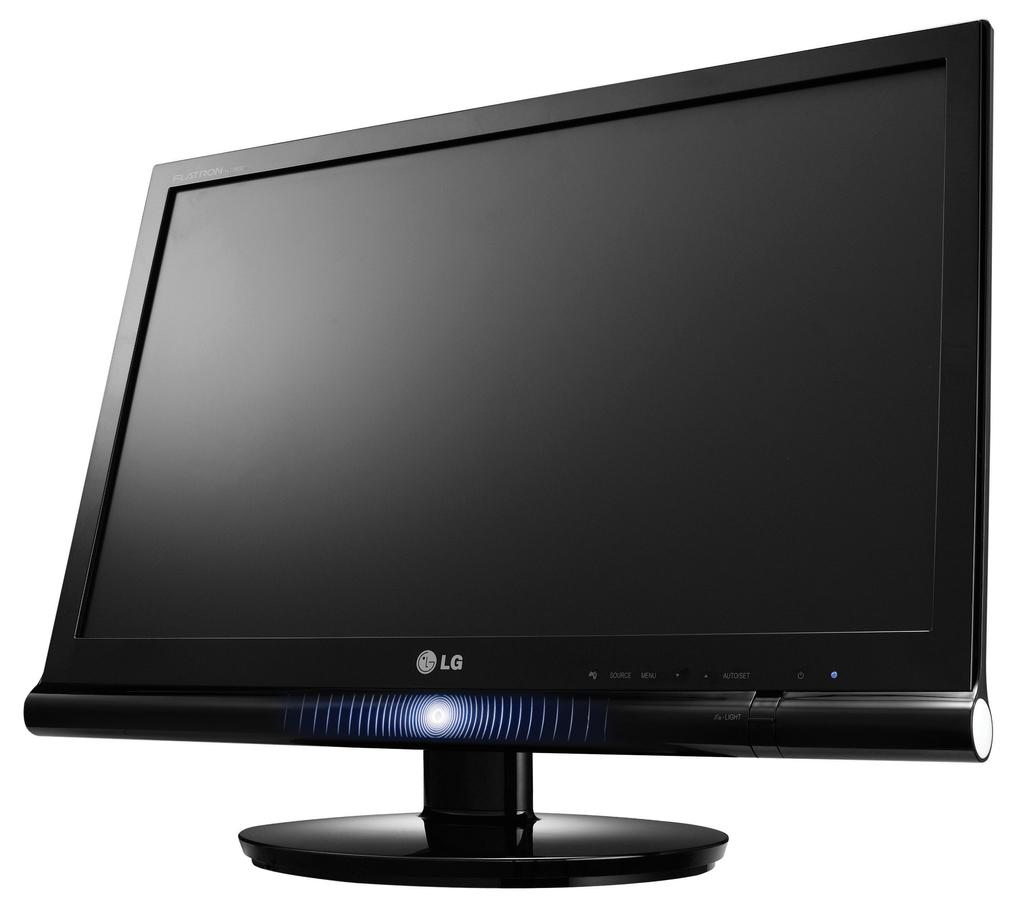<image>
Relay a brief, clear account of the picture shown. A black monitor says LG on the front and is on a white background. 